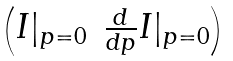Convert formula to latex. <formula><loc_0><loc_0><loc_500><loc_500>\begin{pmatrix} I | _ { p = 0 } & \frac { d } { d p } I | _ { p = 0 } \end{pmatrix}</formula> 